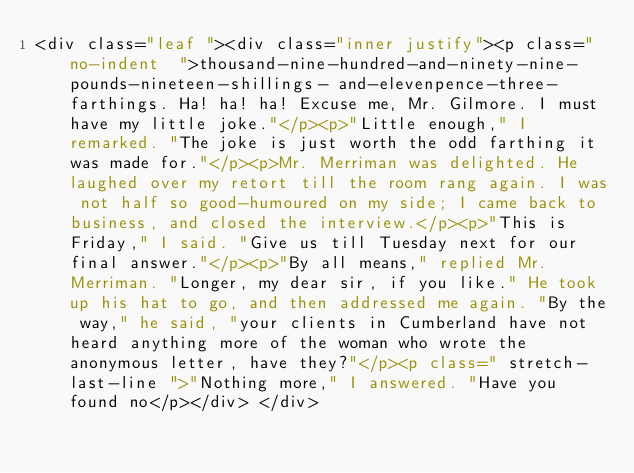Convert code to text. <code><loc_0><loc_0><loc_500><loc_500><_HTML_><div class="leaf "><div class="inner justify"><p class="no-indent  ">thousand-nine-hundred-and-ninety-nine-pounds-nineteen-shillings- and-elevenpence-three-farthings. Ha! ha! ha! Excuse me, Mr. Gilmore. I must have my little joke."</p><p>"Little enough," I remarked. "The joke is just worth the odd farthing it was made for."</p><p>Mr. Merriman was delighted. He laughed over my retort till the room rang again. I was not half so good-humoured on my side; I came back to business, and closed the interview.</p><p>"This is Friday," I said. "Give us till Tuesday next for our final answer."</p><p>"By all means," replied Mr. Merriman. "Longer, my dear sir, if you like." He took up his hat to go, and then addressed me again. "By the way," he said, "your clients in Cumberland have not heard anything more of the woman who wrote the anonymous letter, have they?"</p><p class=" stretch-last-line ">"Nothing more," I answered. "Have you found no</p></div> </div></code> 